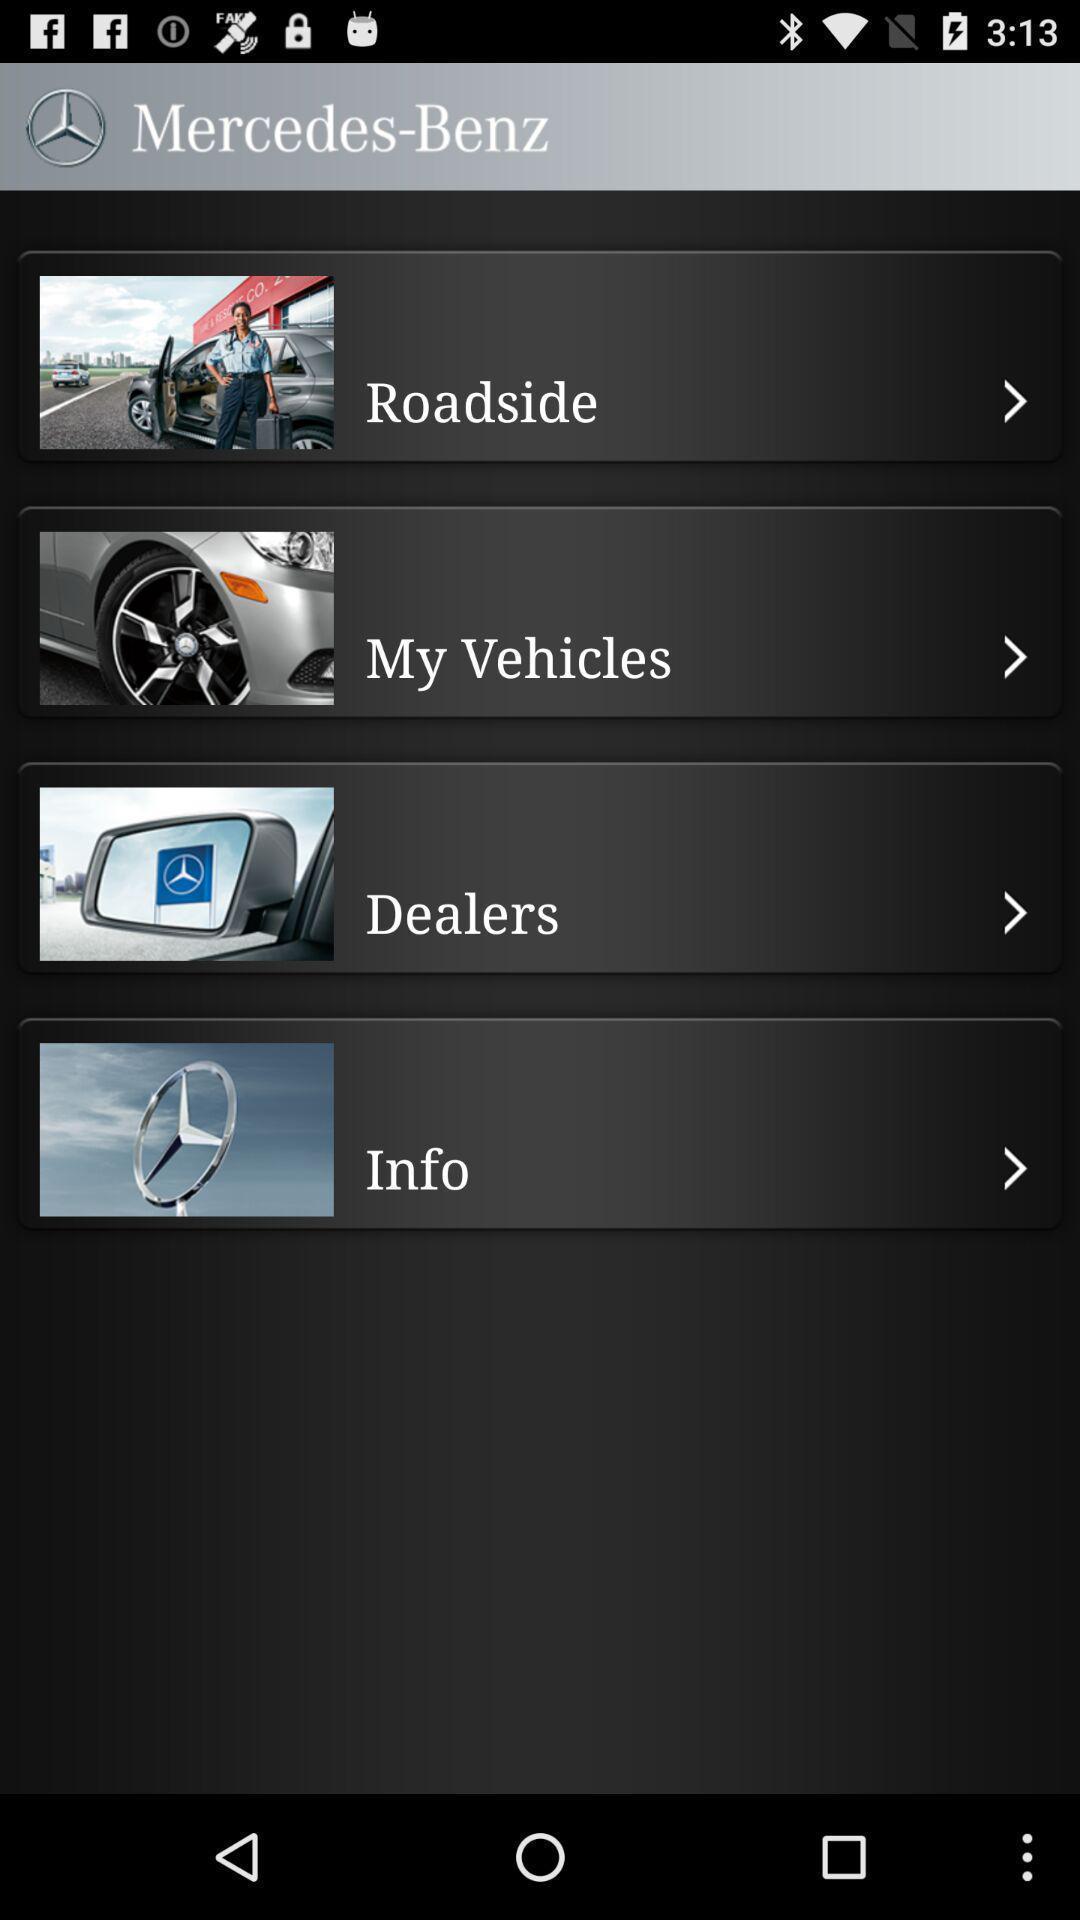Tell me what you see in this picture. Page displaying the different types an a pp. 